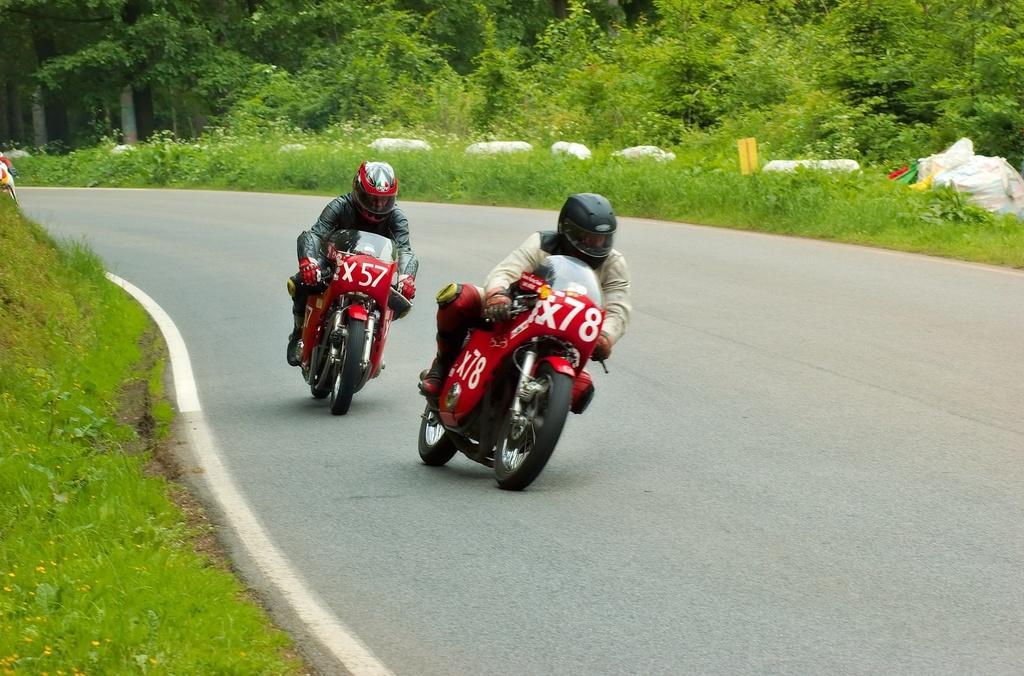Describe this image in one or two sentences. In this picture I can observe two members driving bikes. They are wearing helmets. The bikes are in red color. On either sides of the road I can observe some plants and trees. 